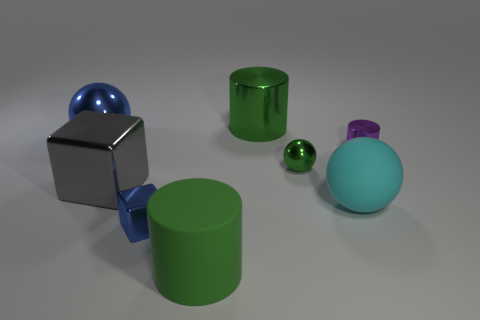Subtract 1 cylinders. How many cylinders are left? 2 Add 1 small gray metal blocks. How many objects exist? 9 Subtract all blocks. How many objects are left? 6 Subtract all small rubber cylinders. Subtract all green cylinders. How many objects are left? 6 Add 4 small cylinders. How many small cylinders are left? 5 Add 5 matte things. How many matte things exist? 7 Subtract 0 gray spheres. How many objects are left? 8 